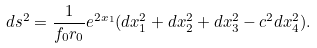Convert formula to latex. <formula><loc_0><loc_0><loc_500><loc_500>d s ^ { 2 } = \frac { 1 } { f _ { 0 } r _ { 0 } } e ^ { 2 x _ { 1 } } ( d x _ { 1 } ^ { 2 } + d x _ { 2 } ^ { 2 } + d x _ { 3 } ^ { 2 } - c ^ { 2 } d x _ { 4 } ^ { 2 } ) .</formula> 